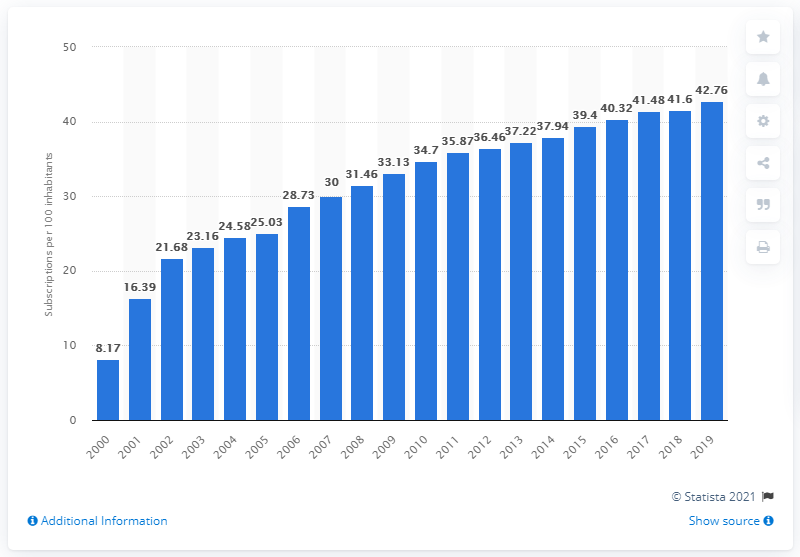Outline some significant characteristics in this image. In 2019, there were 42.76 fixed broadband subscriptions for every 100 inhabitants in Korea. 